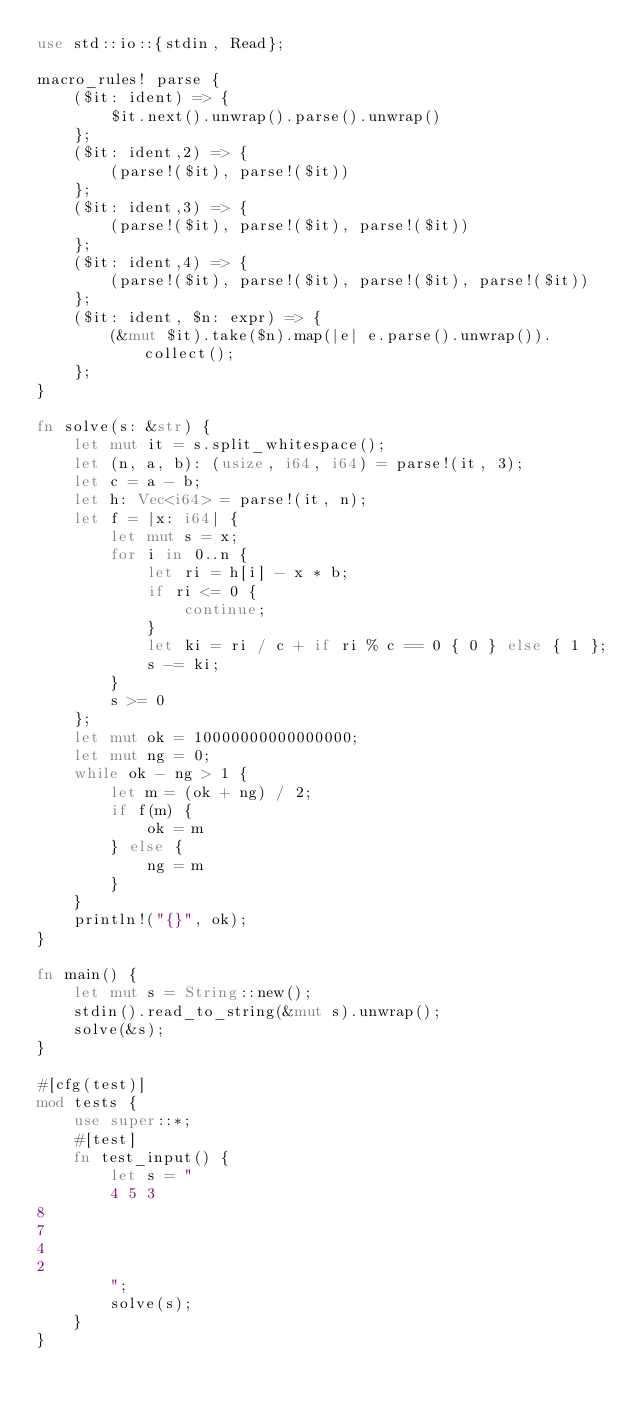Convert code to text. <code><loc_0><loc_0><loc_500><loc_500><_Rust_>use std::io::{stdin, Read};

macro_rules! parse {
    ($it: ident) => {
        $it.next().unwrap().parse().unwrap()
    };
    ($it: ident,2) => {
        (parse!($it), parse!($it))
    };
    ($it: ident,3) => {
        (parse!($it), parse!($it), parse!($it))
    };
    ($it: ident,4) => {
        (parse!($it), parse!($it), parse!($it), parse!($it))
    };
    ($it: ident, $n: expr) => {
        (&mut $it).take($n).map(|e| e.parse().unwrap()).collect();
    };
}

fn solve(s: &str) {
    let mut it = s.split_whitespace();
    let (n, a, b): (usize, i64, i64) = parse!(it, 3);
    let c = a - b;
    let h: Vec<i64> = parse!(it, n);
    let f = |x: i64| {
        let mut s = x;
        for i in 0..n {
            let ri = h[i] - x * b;
            if ri <= 0 {
                continue;
            }
            let ki = ri / c + if ri % c == 0 { 0 } else { 1 };
            s -= ki;
        }
        s >= 0
    };
    let mut ok = 10000000000000000;
    let mut ng = 0;
    while ok - ng > 1 {
        let m = (ok + ng) / 2;
        if f(m) {
            ok = m
        } else {
            ng = m
        }
    }
    println!("{}", ok);
}

fn main() {
    let mut s = String::new();
    stdin().read_to_string(&mut s).unwrap();
    solve(&s);
}

#[cfg(test)]
mod tests {
    use super::*;
    #[test]
    fn test_input() {
        let s = "
        4 5 3
8
7
4
2
        ";
        solve(s);
    }
}
</code> 